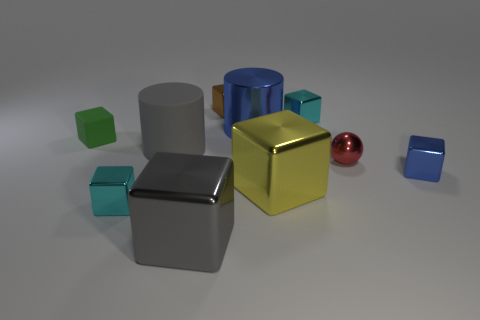Subtract all cyan blocks. How many blocks are left? 5 Subtract all small green matte cubes. How many cubes are left? 6 Subtract all purple blocks. Subtract all gray spheres. How many blocks are left? 7 Subtract all cubes. How many objects are left? 3 Add 1 tiny blue metallic blocks. How many tiny blue metallic blocks exist? 2 Subtract 0 purple cylinders. How many objects are left? 10 Subtract all brown things. Subtract all small red balls. How many objects are left? 8 Add 5 cyan metallic cubes. How many cyan metallic cubes are left? 7 